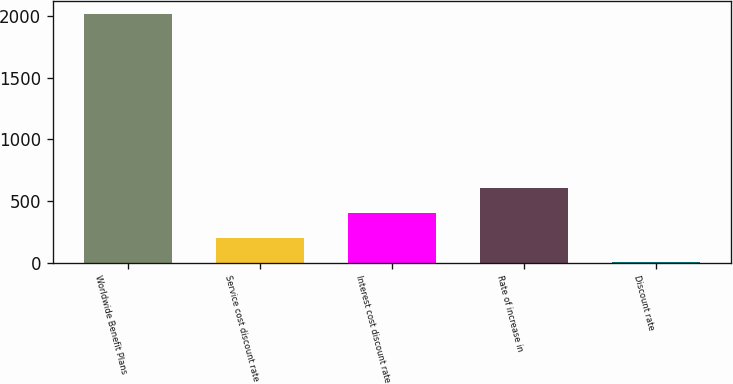Convert chart to OTSL. <chart><loc_0><loc_0><loc_500><loc_500><bar_chart><fcel>Worldwide Benefit Plans<fcel>Service cost discount rate<fcel>Interest cost discount rate<fcel>Rate of increase in<fcel>Discount rate<nl><fcel>2017<fcel>204.67<fcel>406.04<fcel>607.41<fcel>3.3<nl></chart> 